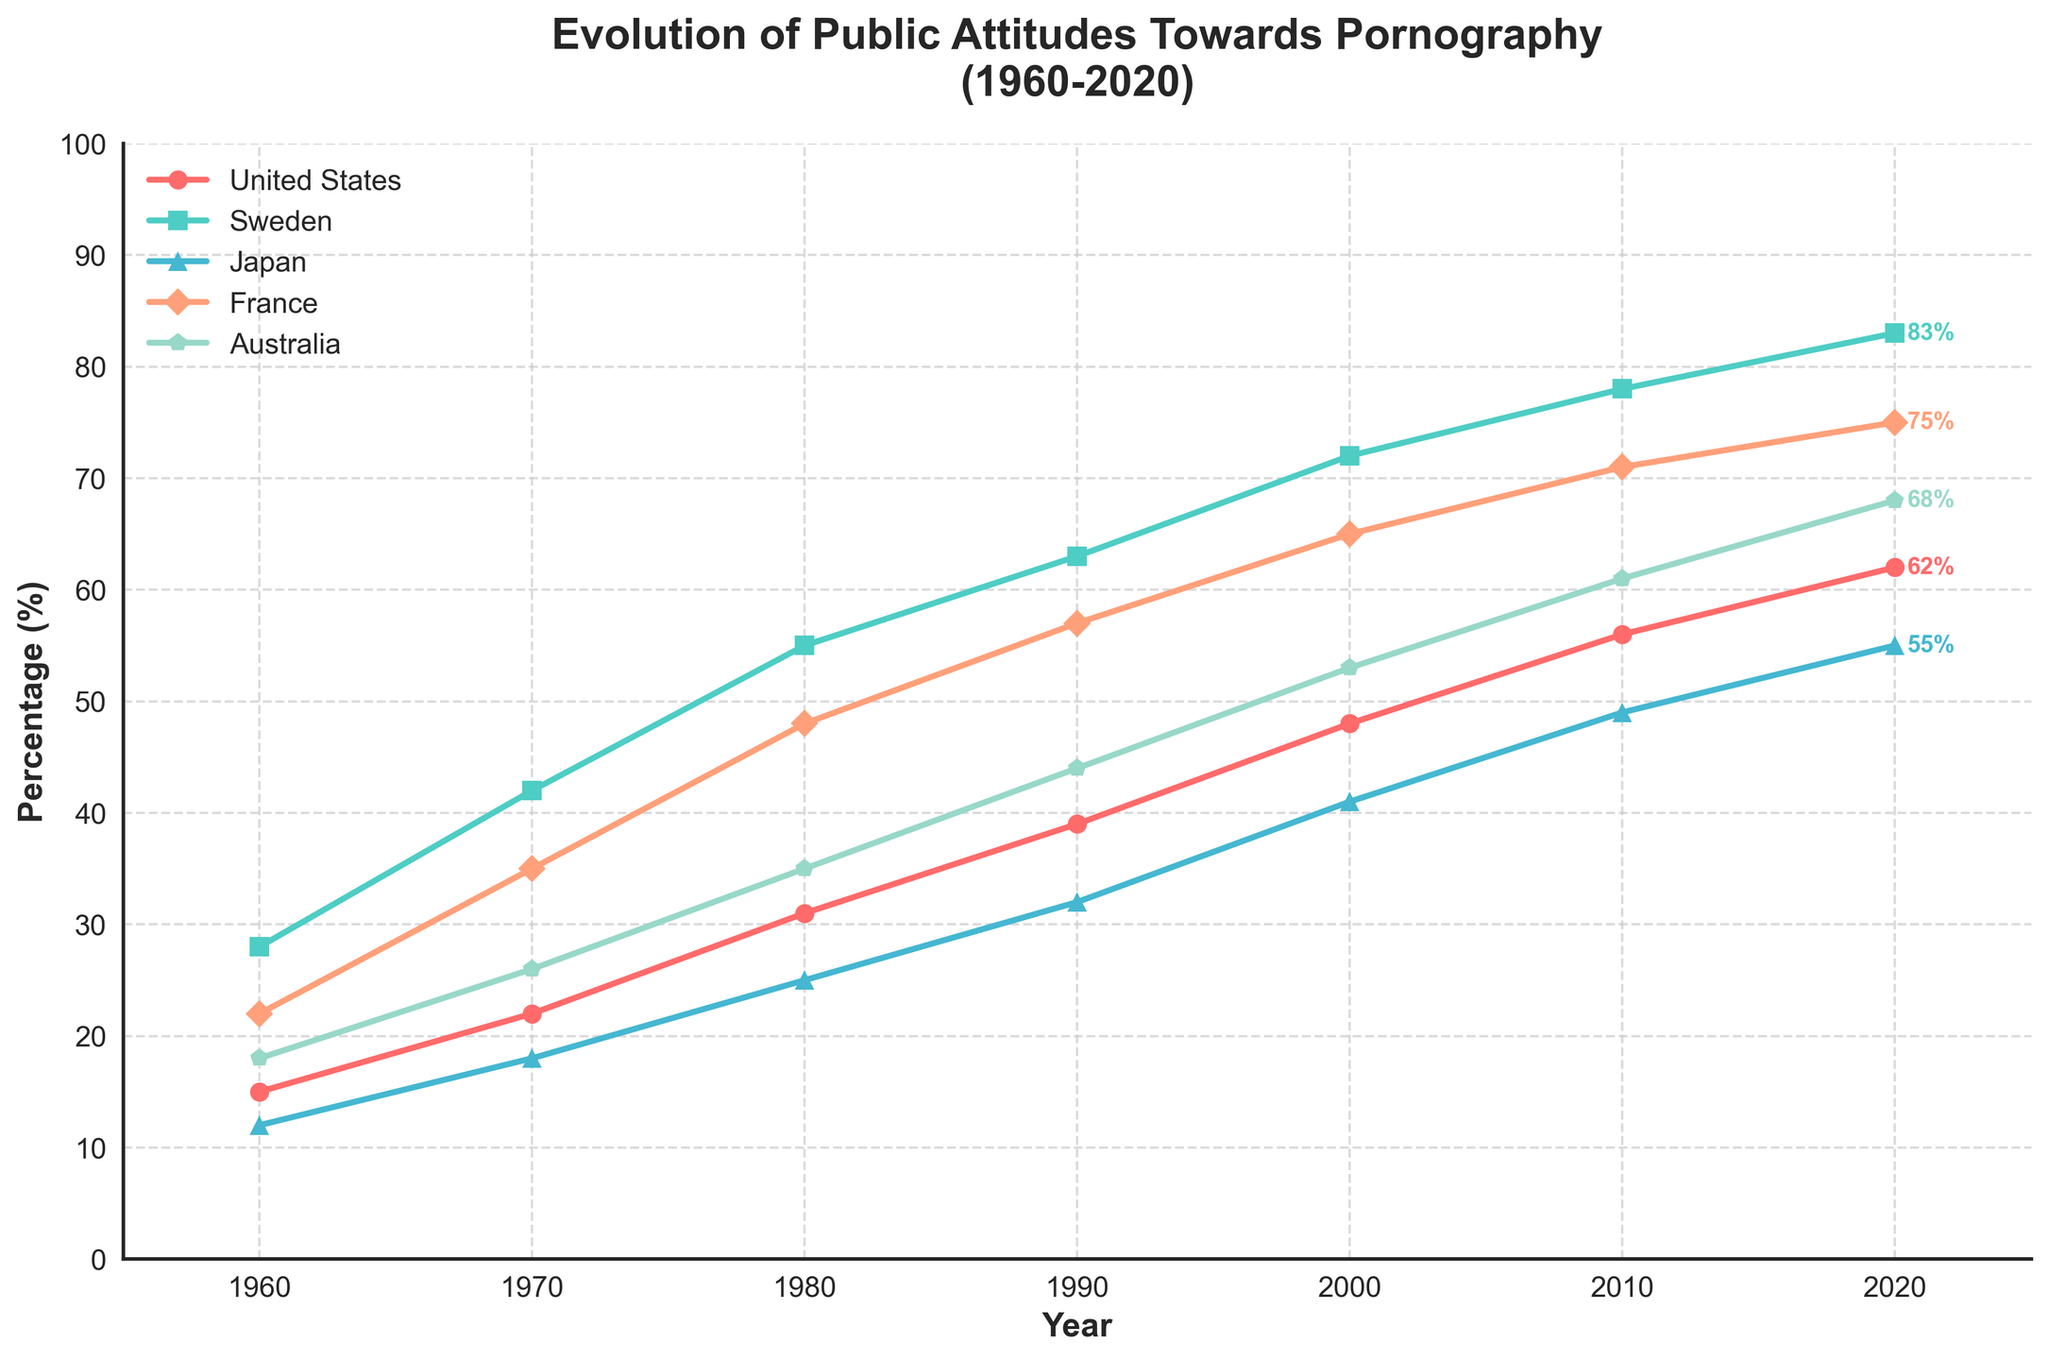What is the percent increase in public acceptance of pornography in the United States from 1960 to 2020? The percentage in the United States in 1960 was 15%, and in 2020, it was 62%. The percent increase is calculated as (62 - 15) / 15 * 100%.
Answer: 313.33% Which country had the highest level of public acceptance of pornography in 2020? By checking the values for 2020, Sweden had the highest level of public acceptance with 83%.
Answer: Sweden Between 1980 and 2000, which country saw the highest absolute increase in public acceptance of pornography? Calculating the differences for each country: 
- United States: 48 - 31 = 17
- Sweden: 72 - 55 = 17
- Japan: 41 - 25 = 16
- France: 65 - 48 = 17
- Australia: 53 - 35 = 18
Australia had the highest increase.
Answer: Australia How did public acceptance of pornography in Japan change between 1960 and 2010? In Japan, the values were 12% in 1960 and 49% in 2010. The difference is 49 - 12 = 37%.
Answer: Increased by 37% Which two countries had the closest levels of public acceptance of pornography in 2010? Looking at the 2010 values:
- United States: 56%
- Sweden: 78%
- Japan: 49%
- France: 71%
- Australia: 61%
The closest values are the United States (56%) and Australia (61%), with a difference of 5%.
Answer: United States and Australia From the figure, which country's trend line shows the steadiest increase over the years? By observing the slopes of the lines over each decade, the United States shows a consistent and steady increase in public acceptance of pornography.
Answer: United States Which country had the slowest increase in public acceptance of pornography from 1960 to 2020? Calculate the overall increase in each country:
- United States: 62 - 15 = 47%
- Sweden: 83 - 28 = 55%
- Japan: 55 - 12 = 43%
- France: 75 - 22 = 53%
- Australia: 68 - 18 = 50%
Japan had the smallest increase at 43%.
Answer: Japan What is the common trend observed in all countries over the 60-year period? All countries show an increasing trend in public acceptance of pornography over the period from 1960 to 2020.
Answer: Increasing trend Which country had the highest public acceptance of pornography throughout the 60-year period, from 1960 to 2020? By evaluating the data across all years, Sweden consistently has the highest public acceptance values in every time frame listed.
Answer: Sweden What was the average public acceptance of pornography in France for the years 1960, 1980, and 2000? Adding the percentages for France in 1960 (22%), 1980 (48%), and 2000 (65%) and then dividing by 3, (22 + 48 + 65) / 3 = 135 / 3 = 45%.
Answer: 45% 